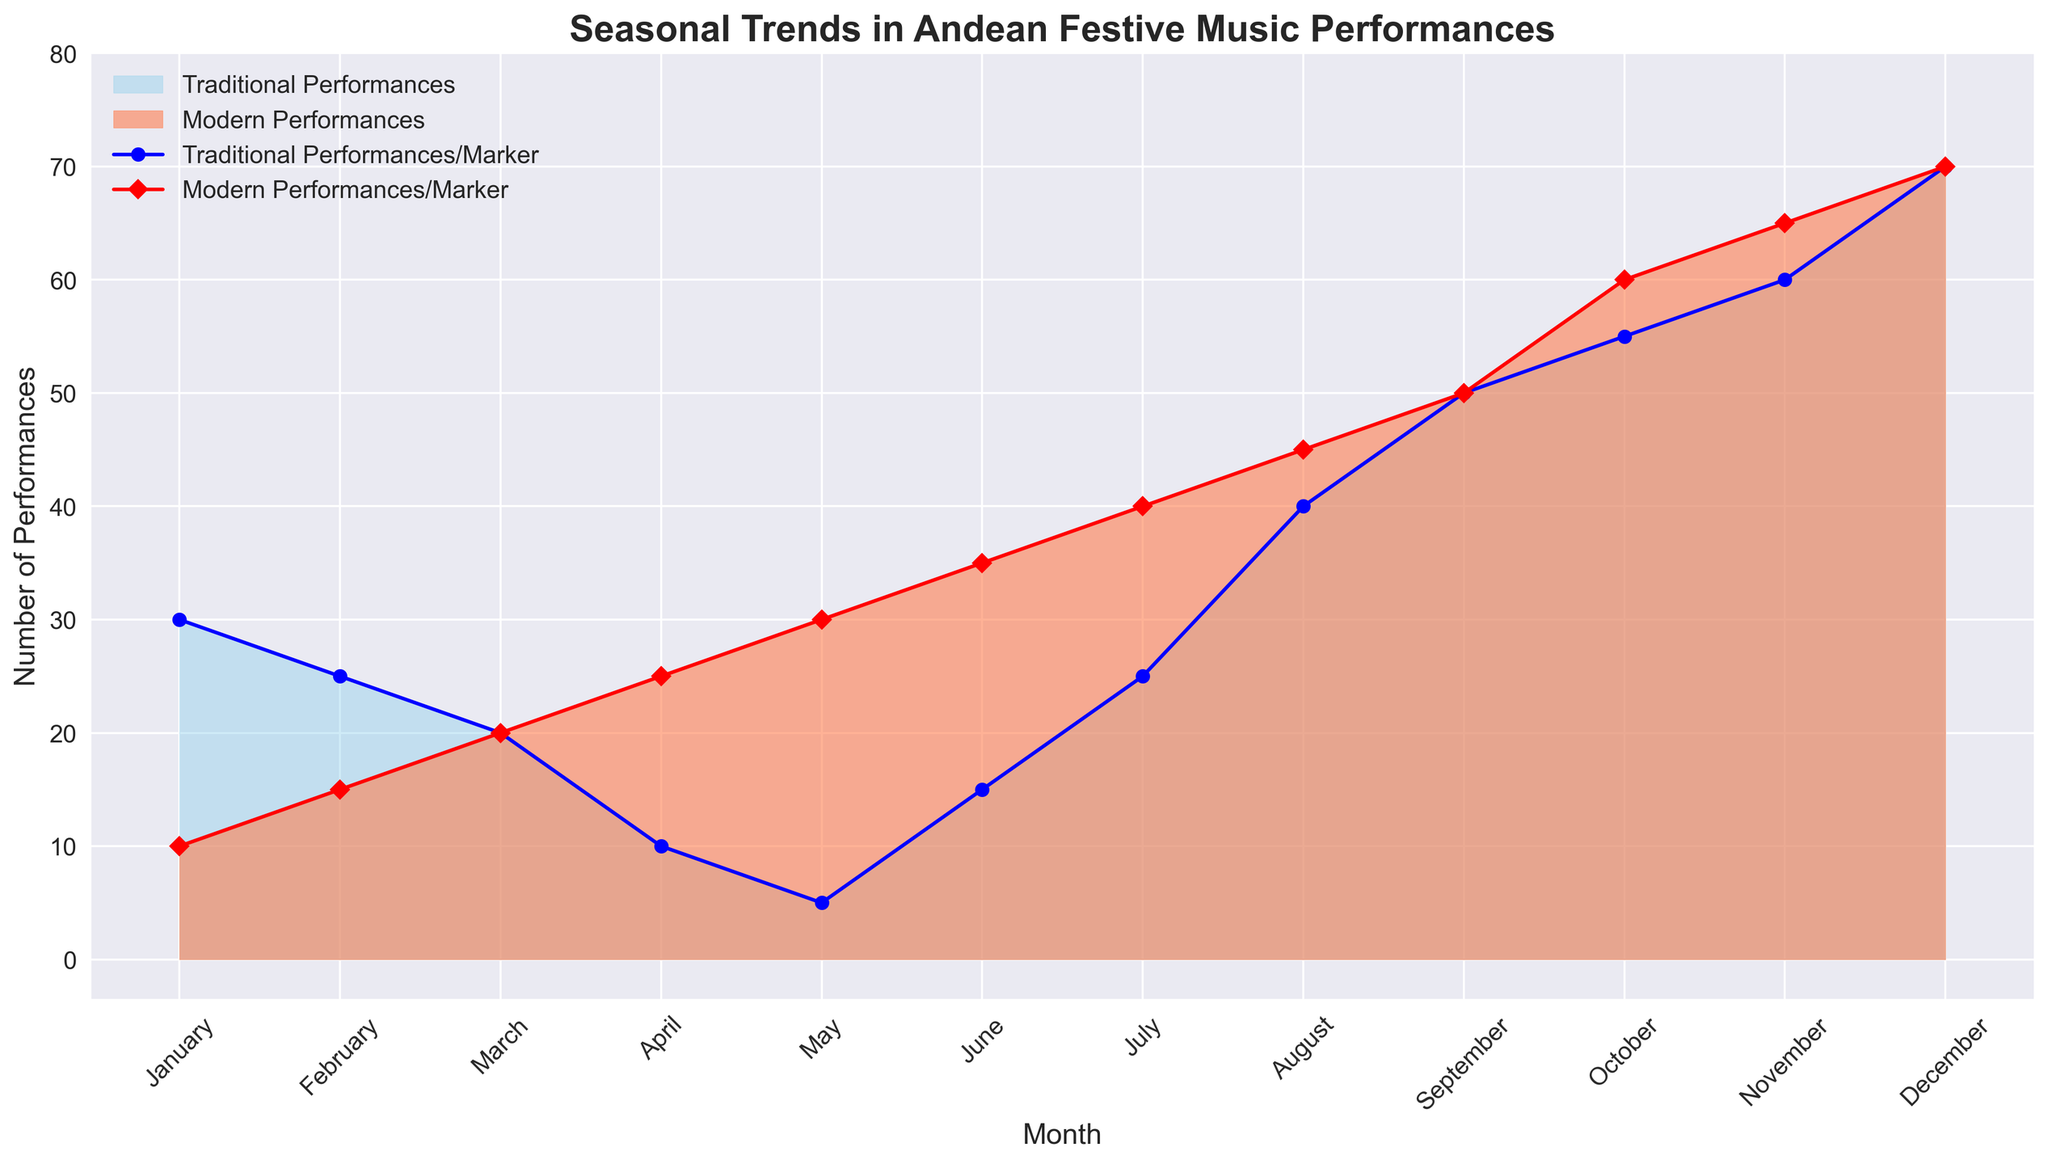What's the trend in Traditional Performances over the year? The number of Traditional Performances generally increases throughout the year, starting at 30 in January and peaking at 70 in December. The trend is upward.
Answer: Upward What is the difference between Traditional and Modern Performances in October? In October, Traditional Performances are at 55, and Modern Performances are at 60. The difference is 60 - 55.
Answer: 5 Which month has the largest number of both Traditional and Modern Performances combined? In December, Traditional Performances are 70 and Modern Performances are also 70, which sums to 140. No other month has a higher combined total.
Answer: December How do the number of Traditional Performances in February compare to July? Traditional Performances in February are 25, while in July they are 25 as well.
Answer: Equal What is the average number of Modern Performances in the first 6 months of the year? The total number of Modern Performances in the first 6 months (January to June) is 10 + 15 + 20 + 25 + 30 + 35 = 135. The average is 135 / 6.
Answer: 22.5 Which month exhibits the most significant difference between Traditional and Modern Performances? September shows a notable difference where Traditional Performances are 50 and Modern Performances are also 50, leading to zero difference.
Answer: September How does the color of the area chart indicate the type of performance? The sky blue color represents Traditional Performances, and the coral color represents Modern Performances.
Answer: Sky blue for Traditional, coral for Modern Which month has the lowest number of Traditional Performances? May has the lowest number of Traditional Performances with only 5 performances recorded.
Answer: May In what month do both types of performances see the same number? In March, both Traditional and Modern Performances are recorded as 20 each.
Answer: March 